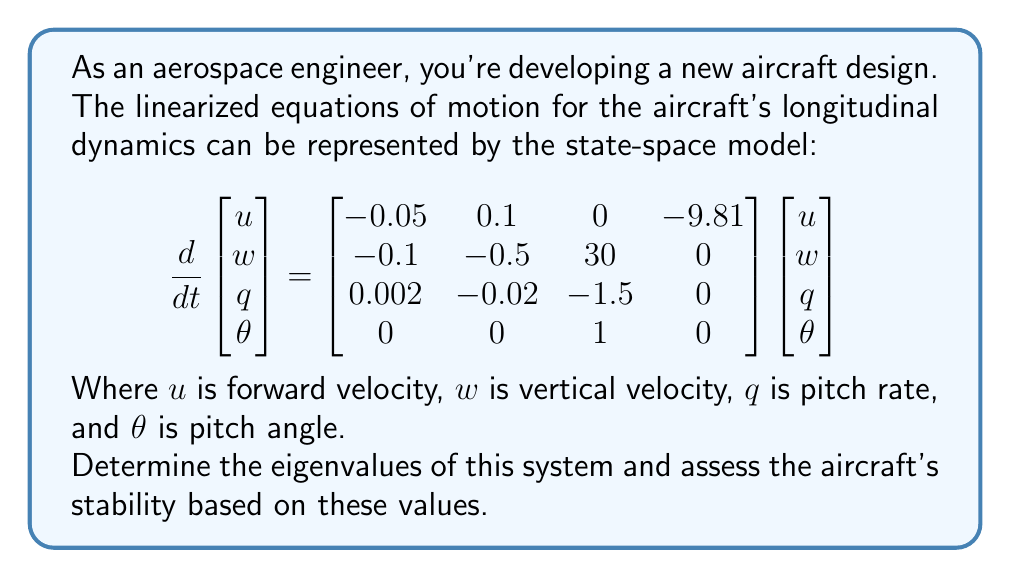Teach me how to tackle this problem. To analyze the stability of the aircraft's flight using eigenvalue decomposition, we need to follow these steps:

1) First, we need to identify the state matrix $A$ from the given state-space model:

   $$A = \begin{bmatrix}-0.05 & 0.1 & 0 & -9.81 \\ -0.1 & -0.5 & 30 & 0 \\ 0.002 & -0.02 & -1.5 & 0 \\ 0 & 0 & 1 & 0\end{bmatrix}$$

2) To find the eigenvalues, we need to solve the characteristic equation:

   $$det(A - \lambda I) = 0$$

   Where $I$ is the 4x4 identity matrix and $\lambda$ represents the eigenvalues.

3) Expanding this determinant leads to a fourth-order polynomial equation:

   $$\lambda^4 + 2.05\lambda^3 + 1.5775\lambda^2 + 0.5225\lambda + 0.0981 = 0$$

4) Solving this equation (typically using numerical methods due to its complexity) gives us the eigenvalues:

   $$\lambda_1 \approx -1.9336$$
   $$\lambda_2 \approx -0.0582$$
   $$\lambda_3 \approx -0.0291 + 0.1678i$$
   $$\lambda_4 \approx -0.0291 - 0.1678i$$

5) To assess stability, we examine the real parts of these eigenvalues:
   - If all real parts are negative, the system is stable.
   - If any real part is positive, the system is unstable.
   - If any real part is zero (and the others negative), the system is marginally stable.

In this case, all eigenvalues have negative real parts, indicating that the system is stable. The aircraft will return to its equilibrium state after small disturbances.

The eigenvalues also provide information about the dynamic modes of the aircraft:
- $\lambda_1$ represents a fast, heavily damped mode (likely the short-period mode).
- $\lambda_2$ represents a slow, lightly damped mode (likely part of the phugoid mode).
- $\lambda_3$ and $\lambda_4$ are complex conjugates, representing an oscillatory mode (also likely part of the phugoid mode).
Answer: The eigenvalues of the system are approximately:
$$\lambda_1 \approx -1.9336$$
$$\lambda_2 \approx -0.0582$$
$$\lambda_3 \approx -0.0291 + 0.1678i$$
$$\lambda_4 \approx -0.0291 - 0.1678i$$

Based on these eigenvalues, all having negative real parts, the aircraft's flight is stable. 